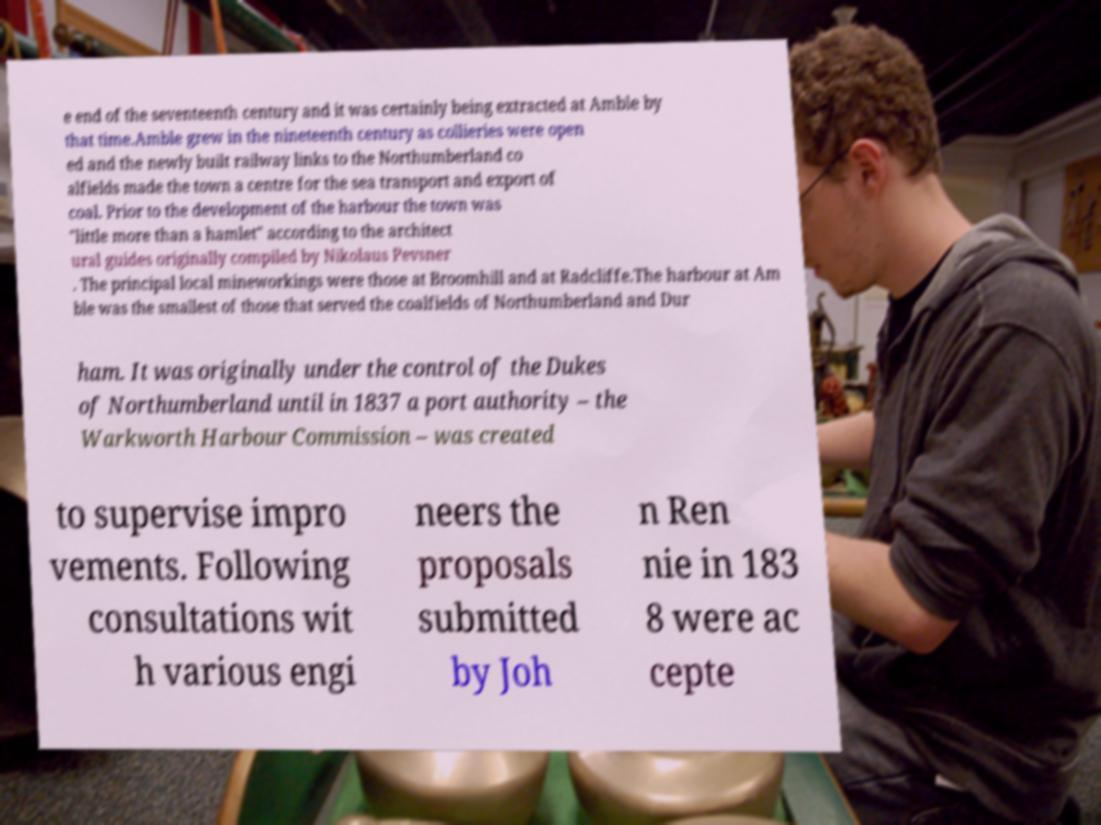Can you accurately transcribe the text from the provided image for me? e end of the seventeenth century and it was certainly being extracted at Amble by that time.Amble grew in the nineteenth century as collieries were open ed and the newly built railway links to the Northumberland co alfields made the town a centre for the sea transport and export of coal. Prior to the development of the harbour the town was "little more than a hamlet" according to the architect ural guides originally compiled by Nikolaus Pevsner . The principal local mineworkings were those at Broomhill and at Radcliffe.The harbour at Am ble was the smallest of those that served the coalfields of Northumberland and Dur ham. It was originally under the control of the Dukes of Northumberland until in 1837 a port authority – the Warkworth Harbour Commission – was created to supervise impro vements. Following consultations wit h various engi neers the proposals submitted by Joh n Ren nie in 183 8 were ac cepte 